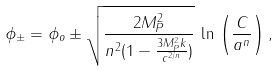Convert formula to latex. <formula><loc_0><loc_0><loc_500><loc_500>\phi _ { \pm } = \phi _ { o } \pm \sqrt { \frac { 2 M _ { P } ^ { 2 } } { n ^ { 2 } ( 1 - \frac { 3 M _ { P } ^ { 2 } k } { c ^ { 2 / n } } ) } } \, \ln \, \left ( \frac { C } { a ^ { n } } \right ) ,</formula> 